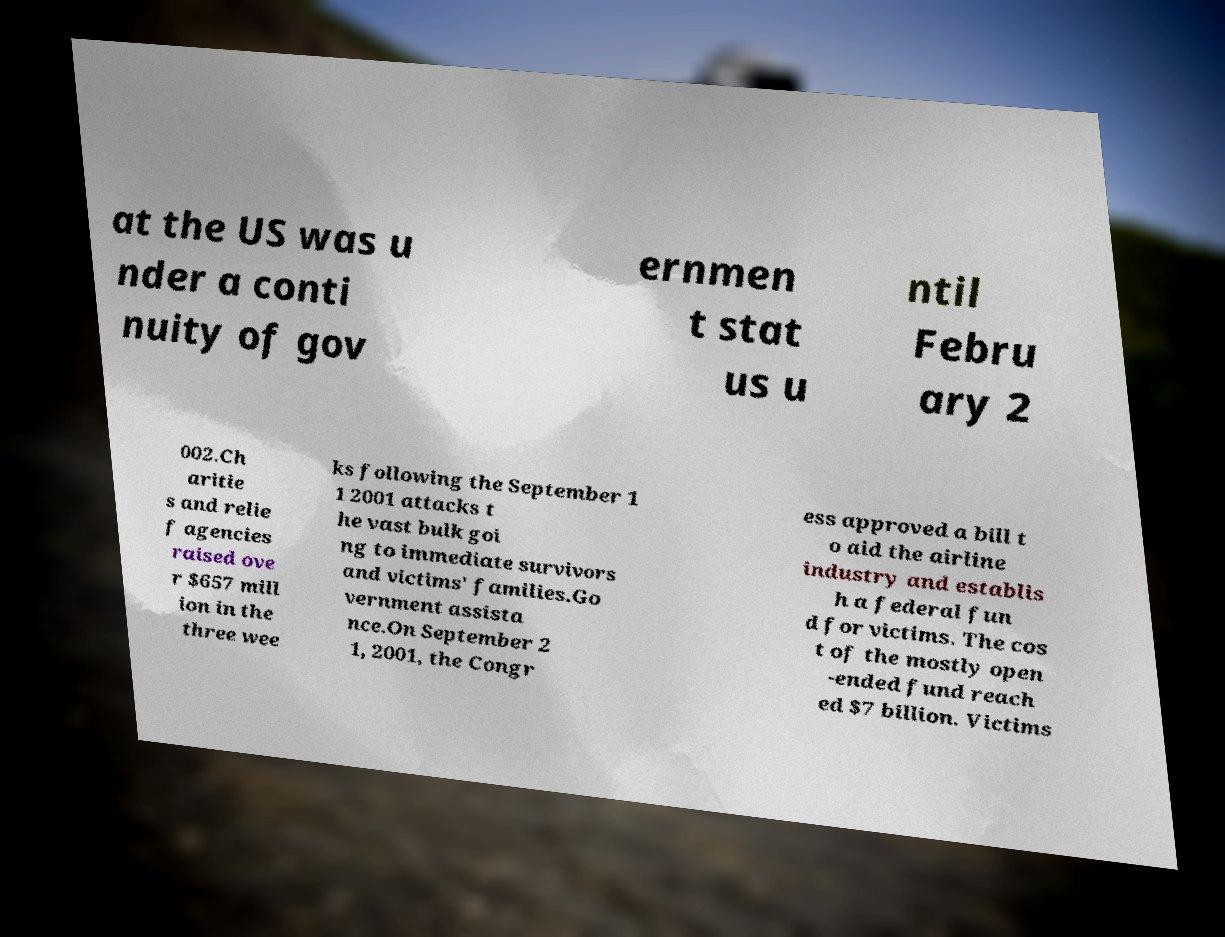Please read and relay the text visible in this image. What does it say? at the US was u nder a conti nuity of gov ernmen t stat us u ntil Febru ary 2 002.Ch aritie s and relie f agencies raised ove r $657 mill ion in the three wee ks following the September 1 1 2001 attacks t he vast bulk goi ng to immediate survivors and victims' families.Go vernment assista nce.On September 2 1, 2001, the Congr ess approved a bill t o aid the airline industry and establis h a federal fun d for victims. The cos t of the mostly open -ended fund reach ed $7 billion. Victims 